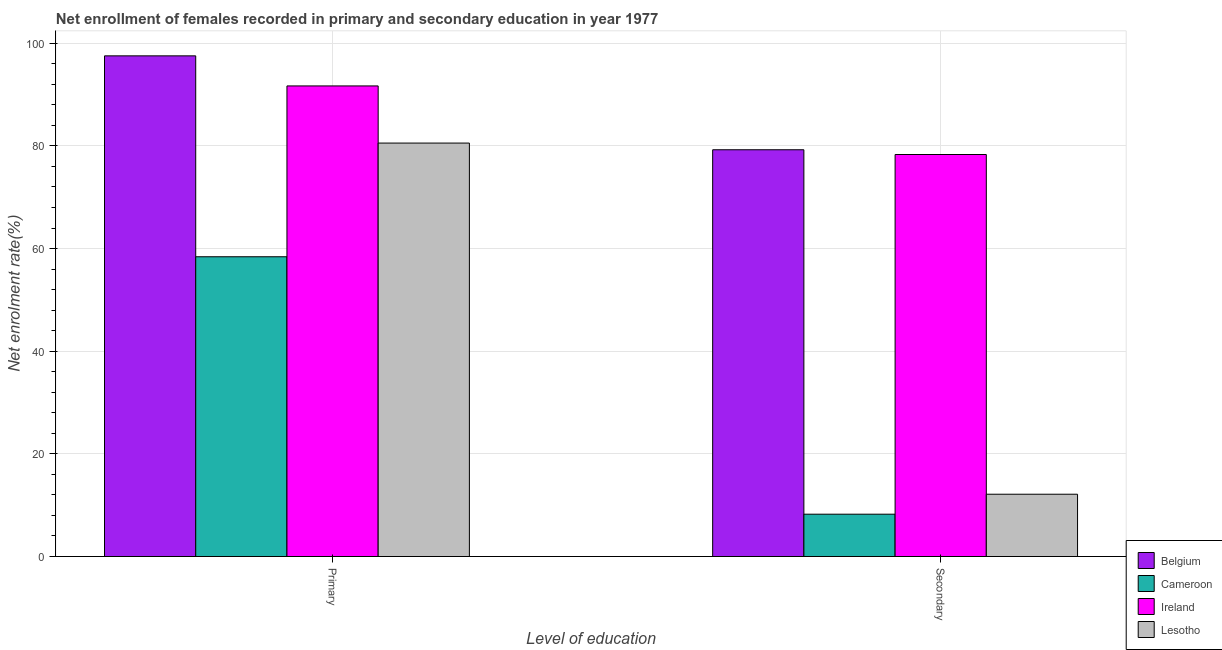How many different coloured bars are there?
Offer a very short reply. 4. How many bars are there on the 1st tick from the left?
Give a very brief answer. 4. What is the label of the 1st group of bars from the left?
Provide a succinct answer. Primary. What is the enrollment rate in secondary education in Cameroon?
Keep it short and to the point. 8.25. Across all countries, what is the maximum enrollment rate in secondary education?
Your answer should be very brief. 79.25. Across all countries, what is the minimum enrollment rate in secondary education?
Offer a terse response. 8.25. In which country was the enrollment rate in secondary education maximum?
Keep it short and to the point. Belgium. In which country was the enrollment rate in secondary education minimum?
Provide a succinct answer. Cameroon. What is the total enrollment rate in secondary education in the graph?
Your response must be concise. 177.96. What is the difference between the enrollment rate in secondary education in Belgium and that in Cameroon?
Offer a terse response. 71.01. What is the difference between the enrollment rate in primary education in Lesotho and the enrollment rate in secondary education in Ireland?
Offer a very short reply. 2.23. What is the average enrollment rate in primary education per country?
Your answer should be compact. 82.05. What is the difference between the enrollment rate in primary education and enrollment rate in secondary education in Belgium?
Offer a very short reply. 18.29. In how many countries, is the enrollment rate in secondary education greater than 44 %?
Your answer should be compact. 2. What is the ratio of the enrollment rate in primary education in Lesotho to that in Ireland?
Your response must be concise. 0.88. Is the enrollment rate in primary education in Ireland less than that in Belgium?
Keep it short and to the point. Yes. In how many countries, is the enrollment rate in primary education greater than the average enrollment rate in primary education taken over all countries?
Keep it short and to the point. 2. What does the 4th bar from the left in Secondary represents?
Provide a succinct answer. Lesotho. What does the 4th bar from the right in Primary represents?
Ensure brevity in your answer.  Belgium. How many countries are there in the graph?
Offer a very short reply. 4. What is the difference between two consecutive major ticks on the Y-axis?
Offer a terse response. 20. Does the graph contain any zero values?
Provide a short and direct response. No. Where does the legend appear in the graph?
Offer a terse response. Bottom right. How many legend labels are there?
Offer a terse response. 4. How are the legend labels stacked?
Provide a short and direct response. Vertical. What is the title of the graph?
Offer a terse response. Net enrollment of females recorded in primary and secondary education in year 1977. Does "Haiti" appear as one of the legend labels in the graph?
Your answer should be very brief. No. What is the label or title of the X-axis?
Provide a short and direct response. Level of education. What is the label or title of the Y-axis?
Your answer should be very brief. Net enrolment rate(%). What is the Net enrolment rate(%) in Belgium in Primary?
Provide a short and direct response. 97.54. What is the Net enrolment rate(%) of Cameroon in Primary?
Offer a terse response. 58.4. What is the Net enrolment rate(%) in Ireland in Primary?
Give a very brief answer. 91.69. What is the Net enrolment rate(%) of Lesotho in Primary?
Your response must be concise. 80.55. What is the Net enrolment rate(%) in Belgium in Secondary?
Offer a very short reply. 79.25. What is the Net enrolment rate(%) of Cameroon in Secondary?
Your answer should be compact. 8.25. What is the Net enrolment rate(%) in Ireland in Secondary?
Offer a terse response. 78.33. What is the Net enrolment rate(%) of Lesotho in Secondary?
Your answer should be very brief. 12.14. Across all Level of education, what is the maximum Net enrolment rate(%) of Belgium?
Your answer should be compact. 97.54. Across all Level of education, what is the maximum Net enrolment rate(%) of Cameroon?
Give a very brief answer. 58.4. Across all Level of education, what is the maximum Net enrolment rate(%) of Ireland?
Ensure brevity in your answer.  91.69. Across all Level of education, what is the maximum Net enrolment rate(%) of Lesotho?
Your response must be concise. 80.55. Across all Level of education, what is the minimum Net enrolment rate(%) in Belgium?
Make the answer very short. 79.25. Across all Level of education, what is the minimum Net enrolment rate(%) of Cameroon?
Ensure brevity in your answer.  8.25. Across all Level of education, what is the minimum Net enrolment rate(%) of Ireland?
Your answer should be compact. 78.33. Across all Level of education, what is the minimum Net enrolment rate(%) of Lesotho?
Your answer should be very brief. 12.14. What is the total Net enrolment rate(%) in Belgium in the graph?
Your answer should be compact. 176.8. What is the total Net enrolment rate(%) in Cameroon in the graph?
Provide a succinct answer. 66.65. What is the total Net enrolment rate(%) of Ireland in the graph?
Give a very brief answer. 170.01. What is the total Net enrolment rate(%) of Lesotho in the graph?
Provide a short and direct response. 92.69. What is the difference between the Net enrolment rate(%) in Belgium in Primary and that in Secondary?
Offer a terse response. 18.29. What is the difference between the Net enrolment rate(%) in Cameroon in Primary and that in Secondary?
Your response must be concise. 50.16. What is the difference between the Net enrolment rate(%) of Ireland in Primary and that in Secondary?
Your answer should be compact. 13.36. What is the difference between the Net enrolment rate(%) in Lesotho in Primary and that in Secondary?
Ensure brevity in your answer.  68.42. What is the difference between the Net enrolment rate(%) of Belgium in Primary and the Net enrolment rate(%) of Cameroon in Secondary?
Offer a terse response. 89.3. What is the difference between the Net enrolment rate(%) in Belgium in Primary and the Net enrolment rate(%) in Ireland in Secondary?
Provide a succinct answer. 19.22. What is the difference between the Net enrolment rate(%) in Belgium in Primary and the Net enrolment rate(%) in Lesotho in Secondary?
Make the answer very short. 85.41. What is the difference between the Net enrolment rate(%) of Cameroon in Primary and the Net enrolment rate(%) of Ireland in Secondary?
Give a very brief answer. -19.92. What is the difference between the Net enrolment rate(%) of Cameroon in Primary and the Net enrolment rate(%) of Lesotho in Secondary?
Your answer should be very brief. 46.27. What is the difference between the Net enrolment rate(%) of Ireland in Primary and the Net enrolment rate(%) of Lesotho in Secondary?
Provide a succinct answer. 79.55. What is the average Net enrolment rate(%) of Belgium per Level of education?
Your response must be concise. 88.4. What is the average Net enrolment rate(%) in Cameroon per Level of education?
Your response must be concise. 33.32. What is the average Net enrolment rate(%) of Ireland per Level of education?
Provide a succinct answer. 85.01. What is the average Net enrolment rate(%) in Lesotho per Level of education?
Offer a terse response. 46.35. What is the difference between the Net enrolment rate(%) in Belgium and Net enrolment rate(%) in Cameroon in Primary?
Provide a succinct answer. 39.14. What is the difference between the Net enrolment rate(%) in Belgium and Net enrolment rate(%) in Ireland in Primary?
Your answer should be very brief. 5.86. What is the difference between the Net enrolment rate(%) in Belgium and Net enrolment rate(%) in Lesotho in Primary?
Offer a very short reply. 16.99. What is the difference between the Net enrolment rate(%) in Cameroon and Net enrolment rate(%) in Ireland in Primary?
Keep it short and to the point. -33.28. What is the difference between the Net enrolment rate(%) of Cameroon and Net enrolment rate(%) of Lesotho in Primary?
Offer a terse response. -22.15. What is the difference between the Net enrolment rate(%) of Ireland and Net enrolment rate(%) of Lesotho in Primary?
Give a very brief answer. 11.13. What is the difference between the Net enrolment rate(%) of Belgium and Net enrolment rate(%) of Cameroon in Secondary?
Offer a terse response. 71.01. What is the difference between the Net enrolment rate(%) of Belgium and Net enrolment rate(%) of Ireland in Secondary?
Provide a succinct answer. 0.93. What is the difference between the Net enrolment rate(%) of Belgium and Net enrolment rate(%) of Lesotho in Secondary?
Make the answer very short. 67.11. What is the difference between the Net enrolment rate(%) of Cameroon and Net enrolment rate(%) of Ireland in Secondary?
Your answer should be compact. -70.08. What is the difference between the Net enrolment rate(%) in Cameroon and Net enrolment rate(%) in Lesotho in Secondary?
Keep it short and to the point. -3.89. What is the difference between the Net enrolment rate(%) of Ireland and Net enrolment rate(%) of Lesotho in Secondary?
Your response must be concise. 66.19. What is the ratio of the Net enrolment rate(%) in Belgium in Primary to that in Secondary?
Keep it short and to the point. 1.23. What is the ratio of the Net enrolment rate(%) in Cameroon in Primary to that in Secondary?
Your response must be concise. 7.08. What is the ratio of the Net enrolment rate(%) of Ireland in Primary to that in Secondary?
Your response must be concise. 1.17. What is the ratio of the Net enrolment rate(%) of Lesotho in Primary to that in Secondary?
Provide a succinct answer. 6.64. What is the difference between the highest and the second highest Net enrolment rate(%) of Belgium?
Your answer should be very brief. 18.29. What is the difference between the highest and the second highest Net enrolment rate(%) in Cameroon?
Provide a short and direct response. 50.16. What is the difference between the highest and the second highest Net enrolment rate(%) of Ireland?
Offer a very short reply. 13.36. What is the difference between the highest and the second highest Net enrolment rate(%) of Lesotho?
Your answer should be compact. 68.42. What is the difference between the highest and the lowest Net enrolment rate(%) of Belgium?
Give a very brief answer. 18.29. What is the difference between the highest and the lowest Net enrolment rate(%) of Cameroon?
Ensure brevity in your answer.  50.16. What is the difference between the highest and the lowest Net enrolment rate(%) in Ireland?
Offer a very short reply. 13.36. What is the difference between the highest and the lowest Net enrolment rate(%) in Lesotho?
Offer a terse response. 68.42. 